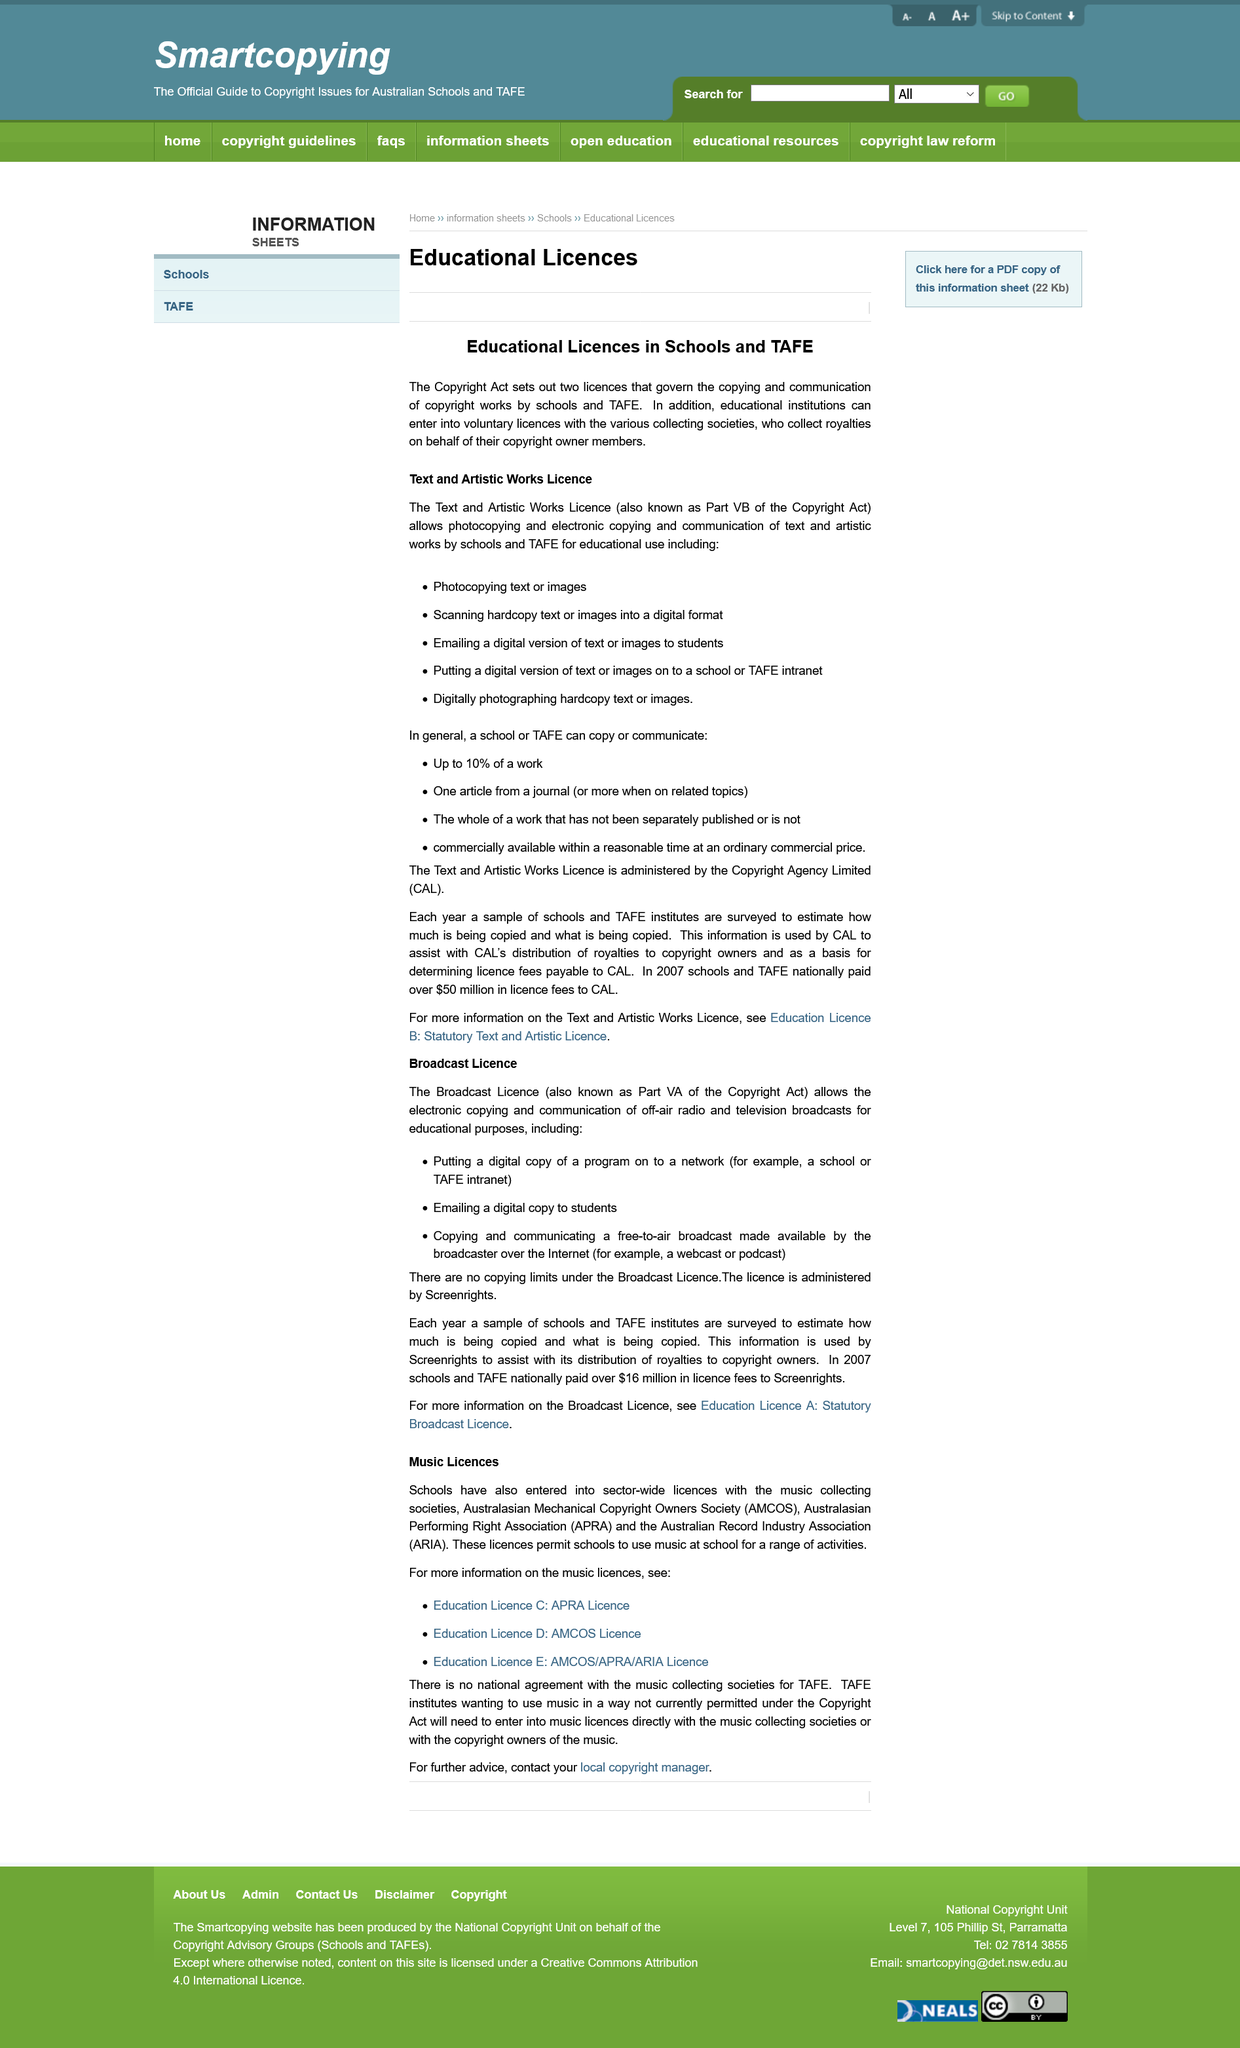Outline some significant characteristics in this image. The Copyright Act sets out two licences that govern the copying and communication of copyright works by schools and TAFE. In 2007, a total of $16 million was paid in licence fees by schools and TAFE nationally to Screenrights. The Text and Artistic Works Licence, also known as Part VB of the Copyright Act, is a licensing agreement that allows for the use of copyrighted works in certain circumstances. The Broadcast Licence is administered by Screenrights. The title of the page is "Music Licences". 